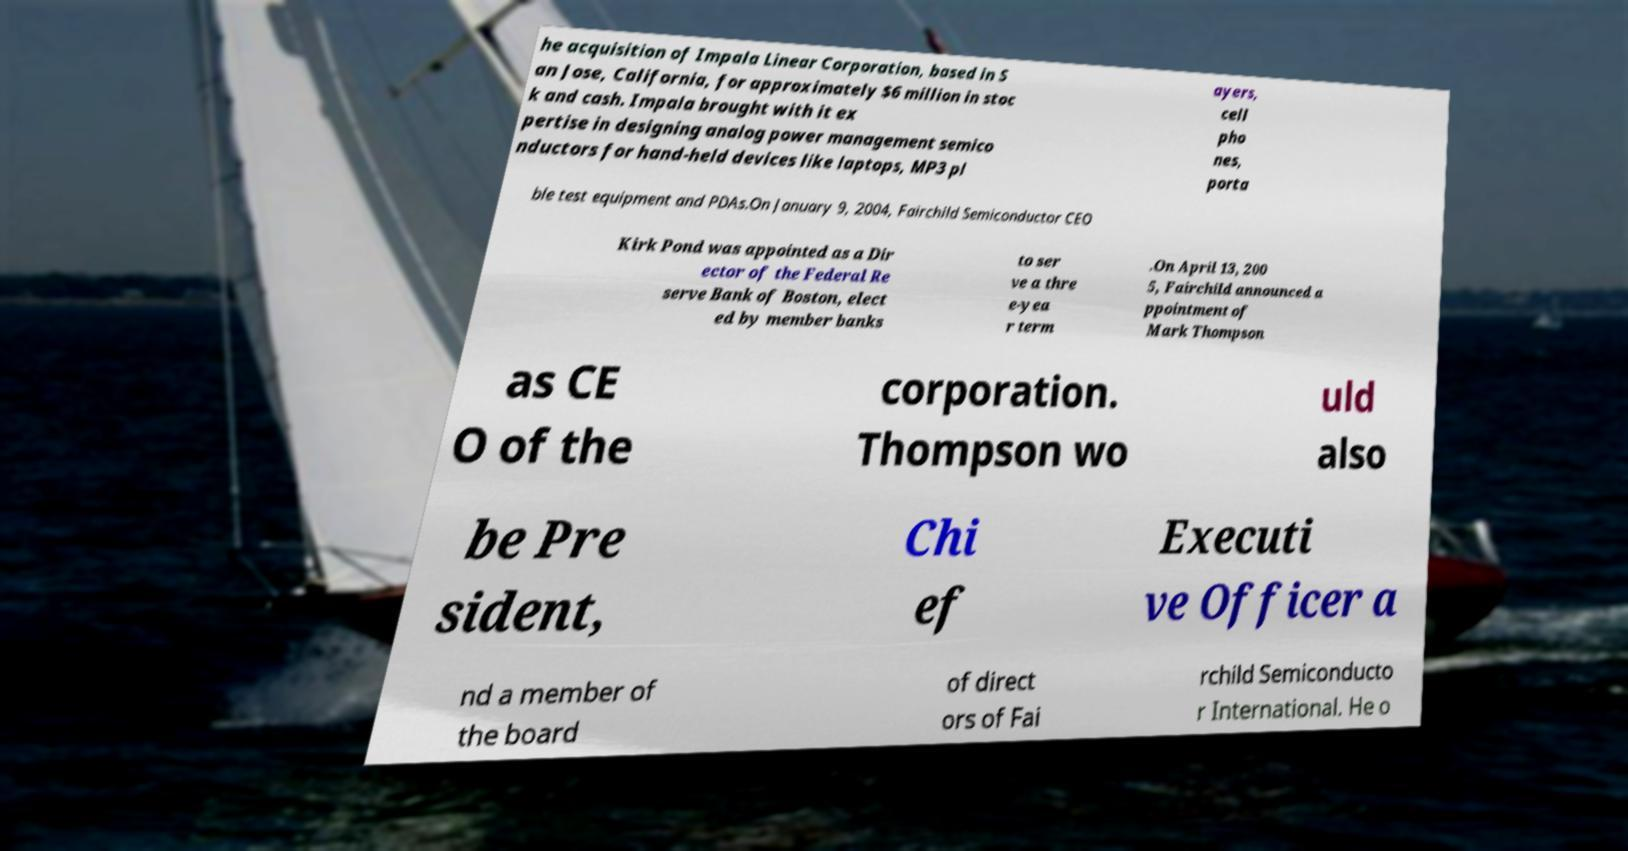There's text embedded in this image that I need extracted. Can you transcribe it verbatim? he acquisition of Impala Linear Corporation, based in S an Jose, California, for approximately $6 million in stoc k and cash. Impala brought with it ex pertise in designing analog power management semico nductors for hand-held devices like laptops, MP3 pl ayers, cell pho nes, porta ble test equipment and PDAs.On January 9, 2004, Fairchild Semiconductor CEO Kirk Pond was appointed as a Dir ector of the Federal Re serve Bank of Boston, elect ed by member banks to ser ve a thre e-yea r term .On April 13, 200 5, Fairchild announced a ppointment of Mark Thompson as CE O of the corporation. Thompson wo uld also be Pre sident, Chi ef Executi ve Officer a nd a member of the board of direct ors of Fai rchild Semiconducto r International. He o 